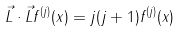<formula> <loc_0><loc_0><loc_500><loc_500>\vec { L } \cdot \vec { L } f ^ { ( j ) } ( x ) = j ( j + 1 ) f ^ { ( j ) } ( x )</formula> 